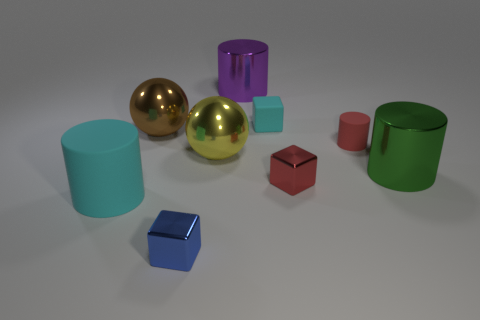How many other things are the same material as the brown thing?
Your response must be concise. 5. What color is the tiny metal object that is in front of the large cyan rubber object?
Give a very brief answer. Blue. What is the material of the small block to the left of the purple object that is on the left side of the tiny cyan rubber thing that is left of the large green shiny thing?
Your response must be concise. Metal. Is there another purple object that has the same shape as the large purple object?
Give a very brief answer. No. What shape is the cyan object that is the same size as the red shiny object?
Provide a succinct answer. Cube. What number of matte objects are both in front of the tiny red cube and behind the big green metallic object?
Make the answer very short. 0. Is the number of tiny red metallic objects to the left of the small blue shiny thing less than the number of small purple matte cubes?
Provide a succinct answer. No. Is there a purple rubber sphere of the same size as the purple shiny object?
Give a very brief answer. No. There is a big cylinder that is the same material as the big green object; what is its color?
Give a very brief answer. Purple. There is a rubber cylinder on the right side of the tiny cyan block; what number of large things are behind it?
Provide a short and direct response. 2. 